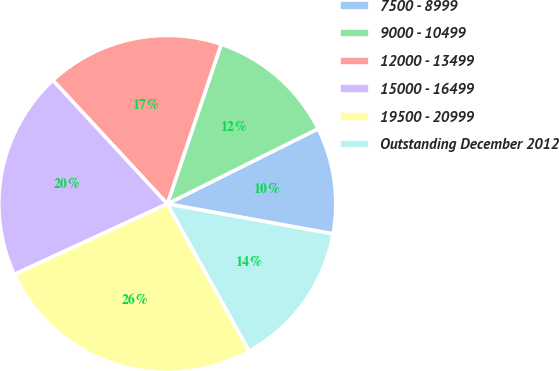Convert chart. <chart><loc_0><loc_0><loc_500><loc_500><pie_chart><fcel>7500 - 8999<fcel>9000 - 10499<fcel>12000 - 13499<fcel>15000 - 16499<fcel>19500 - 20999<fcel>Outstanding December 2012<nl><fcel>10.21%<fcel>12.46%<fcel>17.07%<fcel>19.99%<fcel>26.22%<fcel>14.06%<nl></chart> 